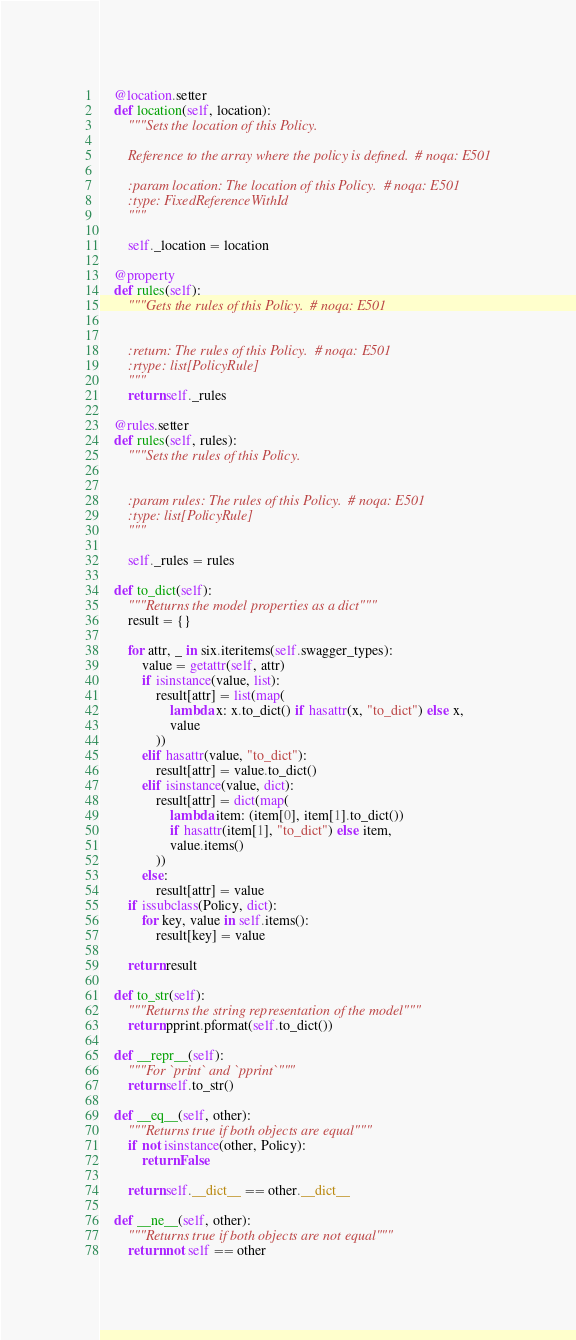Convert code to text. <code><loc_0><loc_0><loc_500><loc_500><_Python_>
    @location.setter
    def location(self, location):
        """Sets the location of this Policy.

        Reference to the array where the policy is defined.  # noqa: E501

        :param location: The location of this Policy.  # noqa: E501
        :type: FixedReferenceWithId
        """

        self._location = location

    @property
    def rules(self):
        """Gets the rules of this Policy.  # noqa: E501


        :return: The rules of this Policy.  # noqa: E501
        :rtype: list[PolicyRule]
        """
        return self._rules

    @rules.setter
    def rules(self, rules):
        """Sets the rules of this Policy.


        :param rules: The rules of this Policy.  # noqa: E501
        :type: list[PolicyRule]
        """

        self._rules = rules

    def to_dict(self):
        """Returns the model properties as a dict"""
        result = {}

        for attr, _ in six.iteritems(self.swagger_types):
            value = getattr(self, attr)
            if isinstance(value, list):
                result[attr] = list(map(
                    lambda x: x.to_dict() if hasattr(x, "to_dict") else x,
                    value
                ))
            elif hasattr(value, "to_dict"):
                result[attr] = value.to_dict()
            elif isinstance(value, dict):
                result[attr] = dict(map(
                    lambda item: (item[0], item[1].to_dict())
                    if hasattr(item[1], "to_dict") else item,
                    value.items()
                ))
            else:
                result[attr] = value
        if issubclass(Policy, dict):
            for key, value in self.items():
                result[key] = value

        return result

    def to_str(self):
        """Returns the string representation of the model"""
        return pprint.pformat(self.to_dict())

    def __repr__(self):
        """For `print` and `pprint`"""
        return self.to_str()

    def __eq__(self, other):
        """Returns true if both objects are equal"""
        if not isinstance(other, Policy):
            return False

        return self.__dict__ == other.__dict__

    def __ne__(self, other):
        """Returns true if both objects are not equal"""
        return not self == other
</code> 